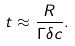<formula> <loc_0><loc_0><loc_500><loc_500>t \approx \frac { R } { \Gamma \delta c } .</formula> 